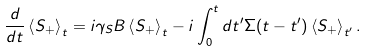Convert formula to latex. <formula><loc_0><loc_0><loc_500><loc_500>\frac { d } { d t } \left < S _ { + } \right > _ { t } = i \gamma _ { S } B \left < S _ { + } \right > _ { t } - i \int _ { 0 } ^ { t } d t ^ { \prime } \Sigma ( t - t ^ { \prime } ) \left < S _ { + } \right > _ { t ^ { \prime } } .</formula> 